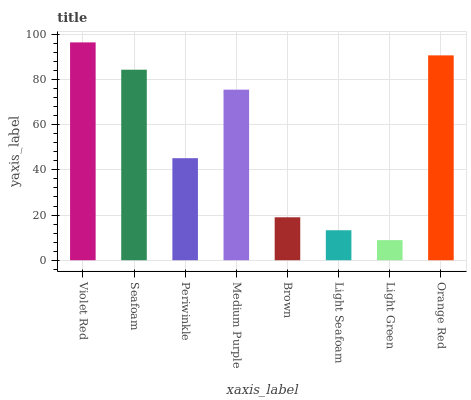Is Light Green the minimum?
Answer yes or no. Yes. Is Violet Red the maximum?
Answer yes or no. Yes. Is Seafoam the minimum?
Answer yes or no. No. Is Seafoam the maximum?
Answer yes or no. No. Is Violet Red greater than Seafoam?
Answer yes or no. Yes. Is Seafoam less than Violet Red?
Answer yes or no. Yes. Is Seafoam greater than Violet Red?
Answer yes or no. No. Is Violet Red less than Seafoam?
Answer yes or no. No. Is Medium Purple the high median?
Answer yes or no. Yes. Is Periwinkle the low median?
Answer yes or no. Yes. Is Periwinkle the high median?
Answer yes or no. No. Is Brown the low median?
Answer yes or no. No. 